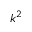<formula> <loc_0><loc_0><loc_500><loc_500>k ^ { 2 }</formula> 